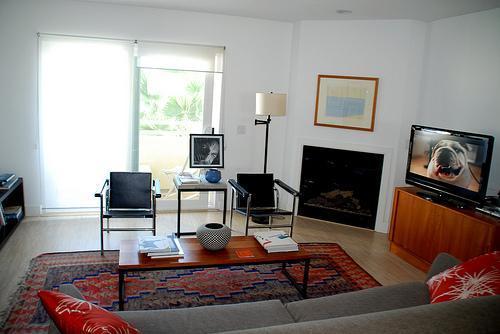How many televisions?
Give a very brief answer. 1. 